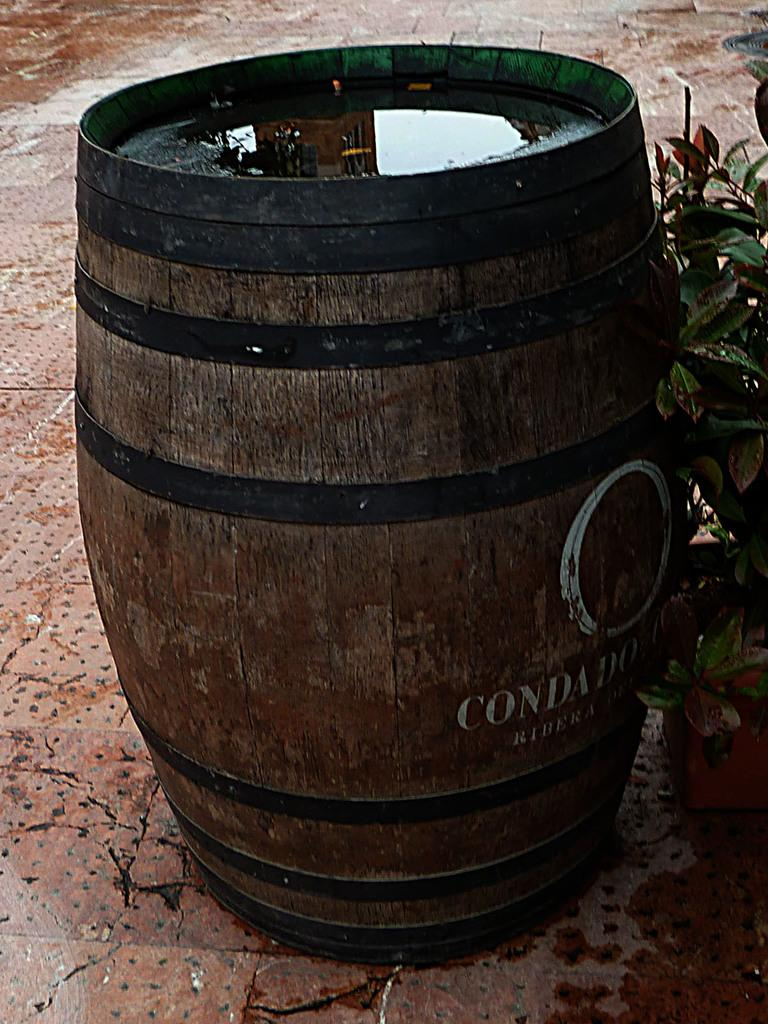<image>
Present a compact description of the photo's key features. Condad brand wood barrel, with water on top. 